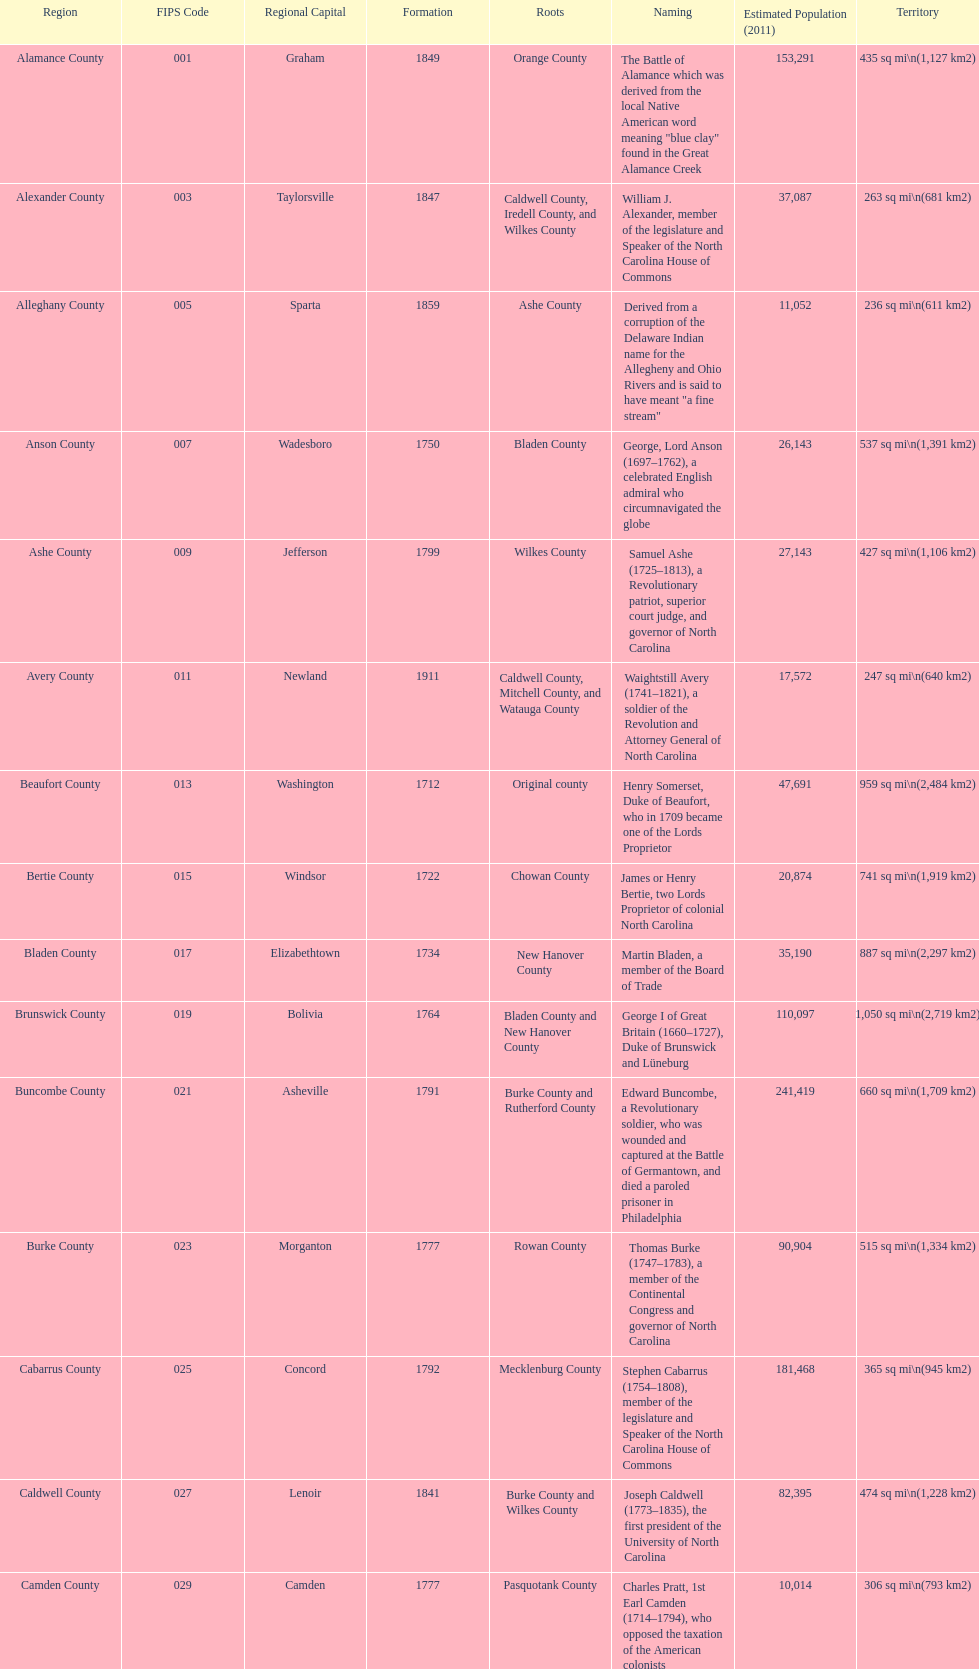Besides mecklenburg, which county has the most significant population? Wake County. 